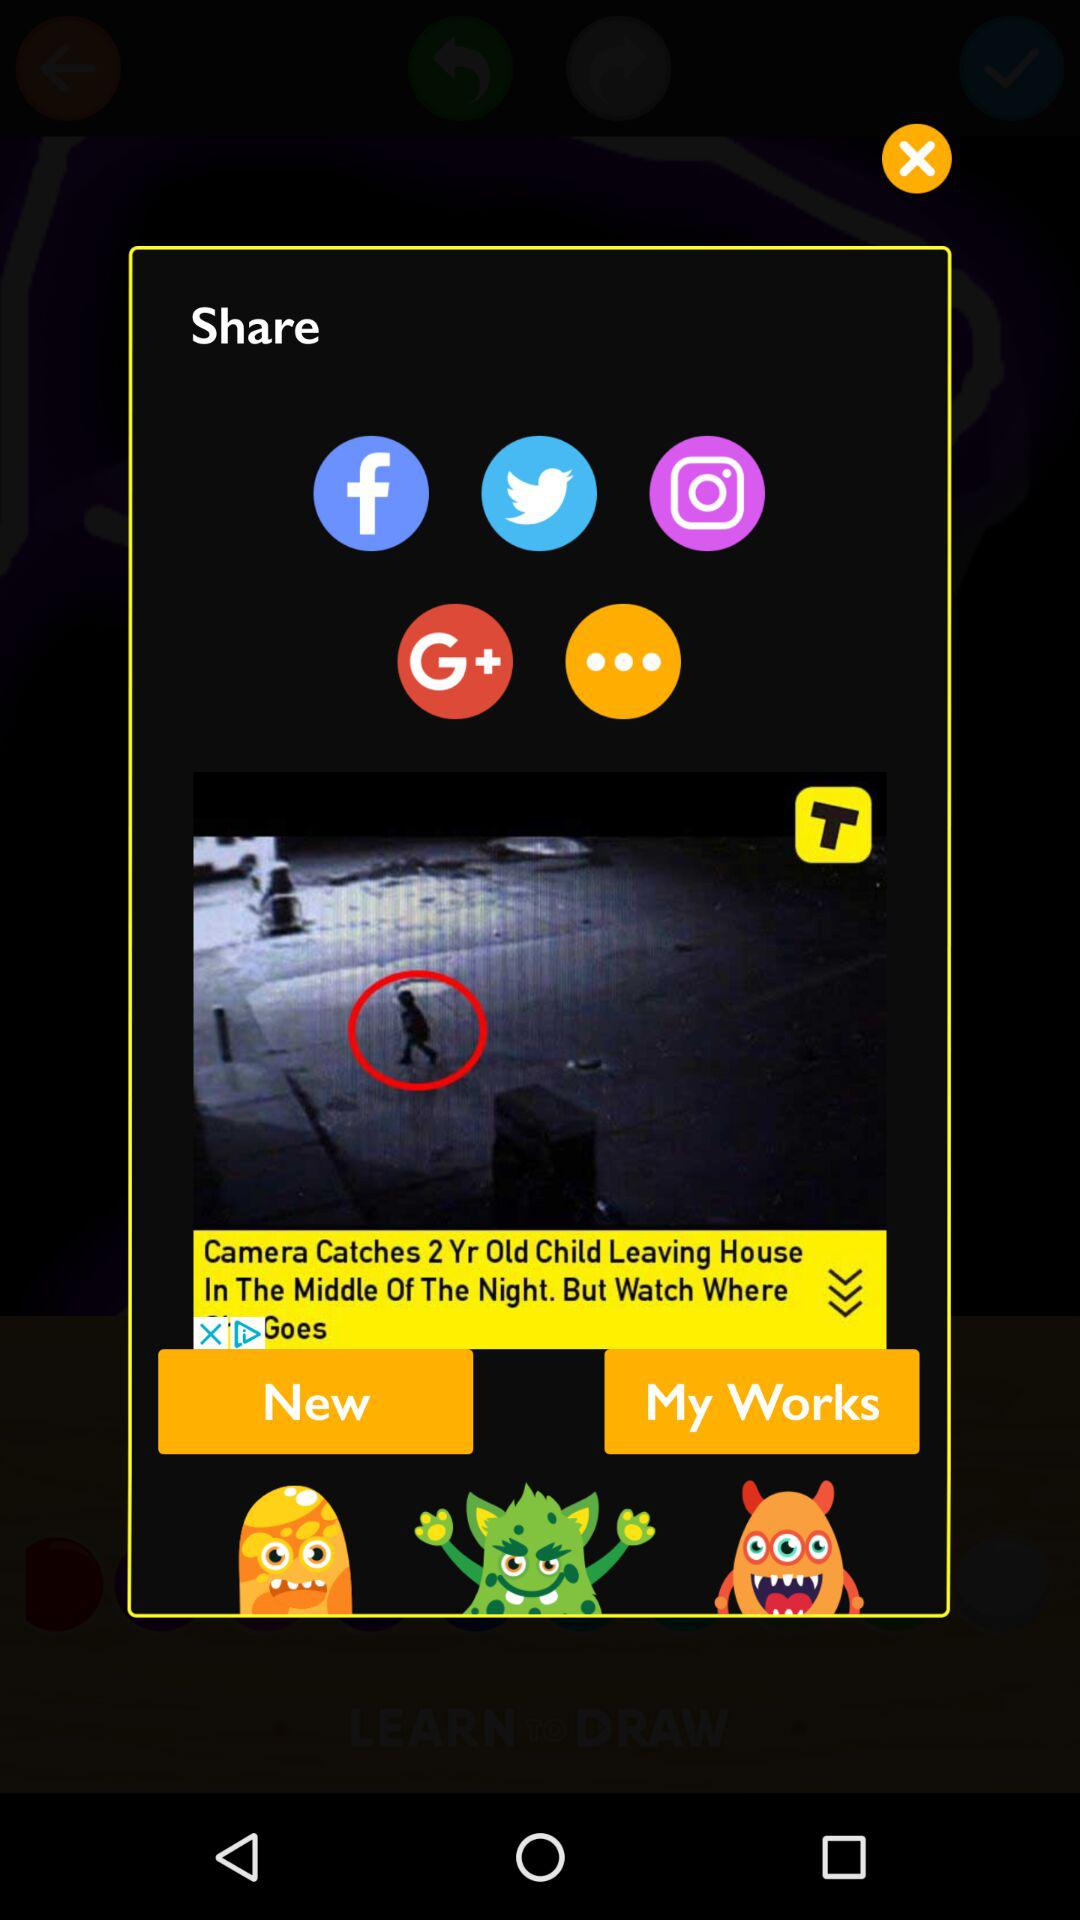Through which app can we share the content? You can share it through "Facebook", "Twitter", "Instagram" and "Google+". 